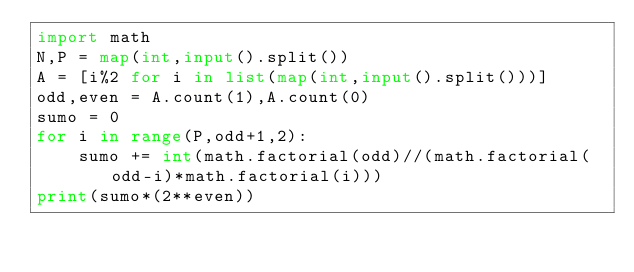Convert code to text. <code><loc_0><loc_0><loc_500><loc_500><_Python_>import math
N,P = map(int,input().split())
A = [i%2 for i in list(map(int,input().split()))]
odd,even = A.count(1),A.count(0)
sumo = 0
for i in range(P,odd+1,2):
    sumo += int(math.factorial(odd)//(math.factorial(odd-i)*math.factorial(i)))
print(sumo*(2**even))</code> 